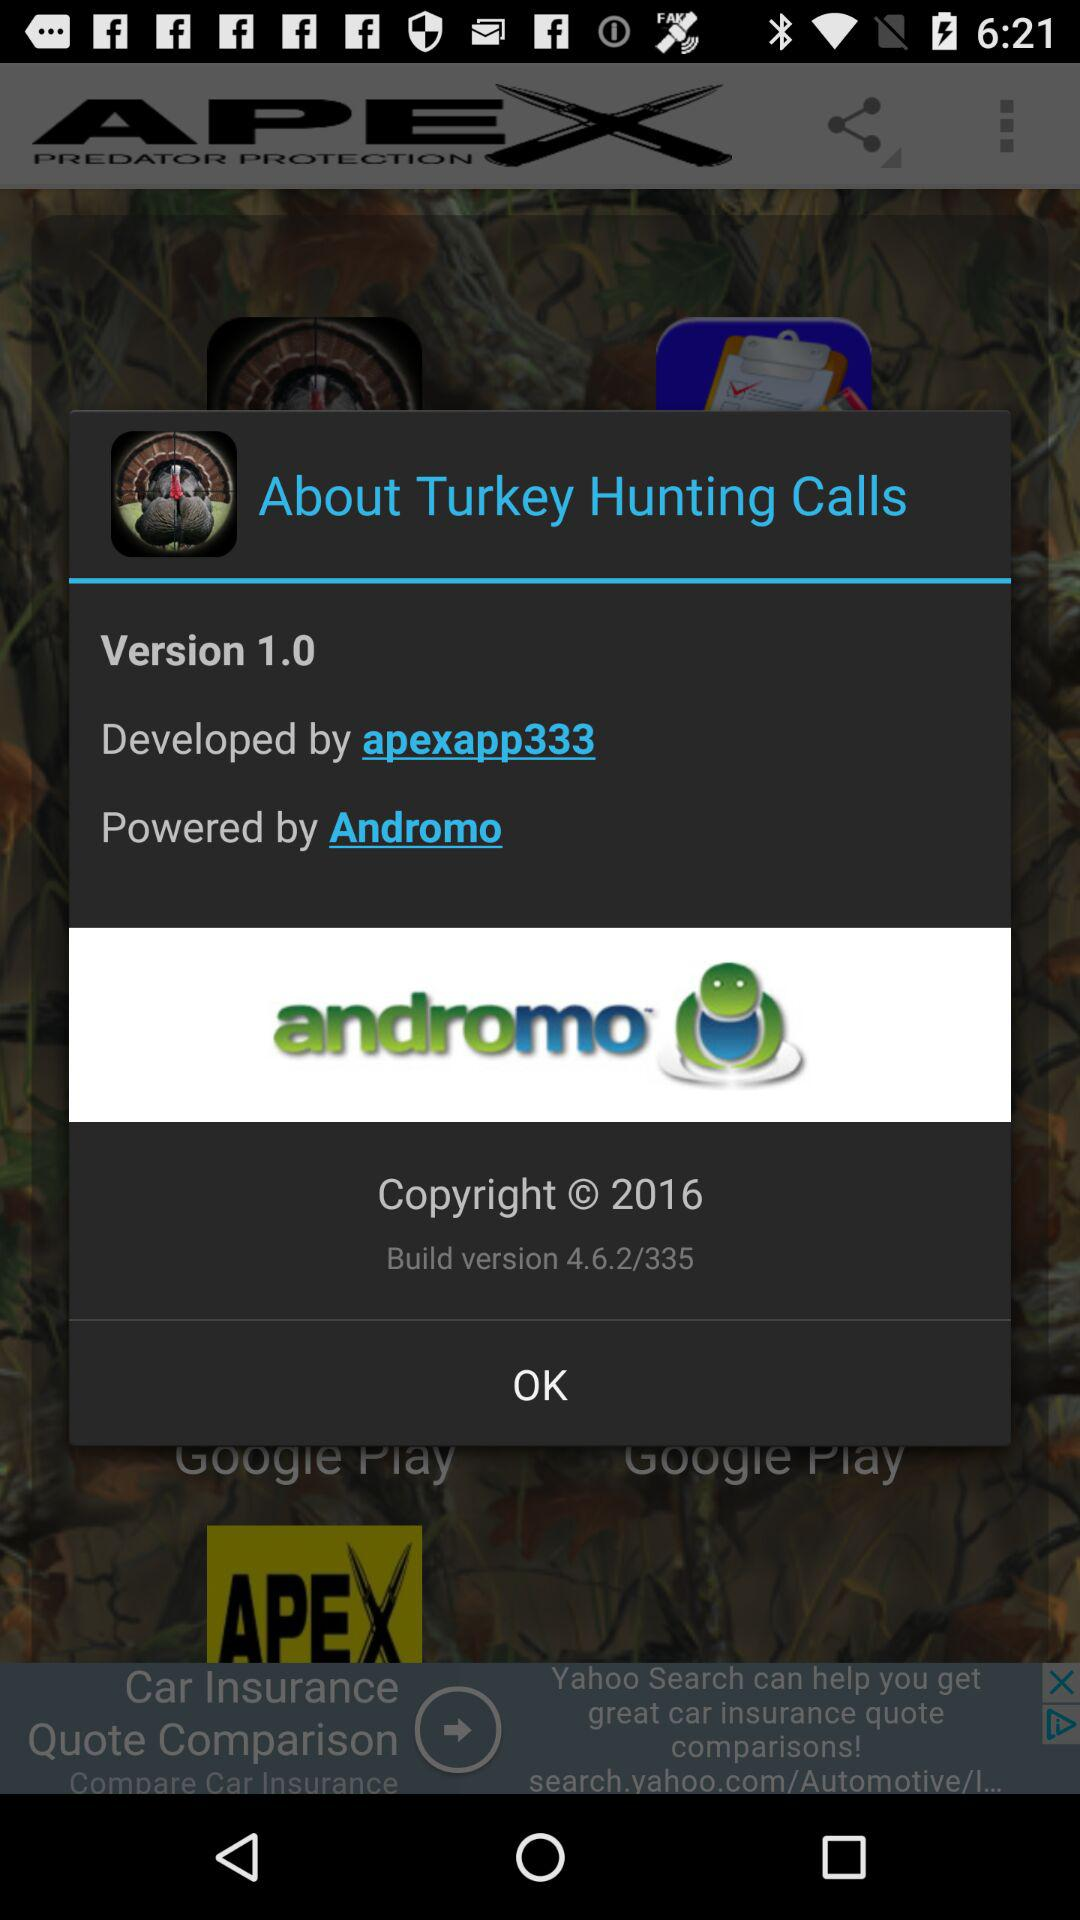What is the version? The version is 1.0. 